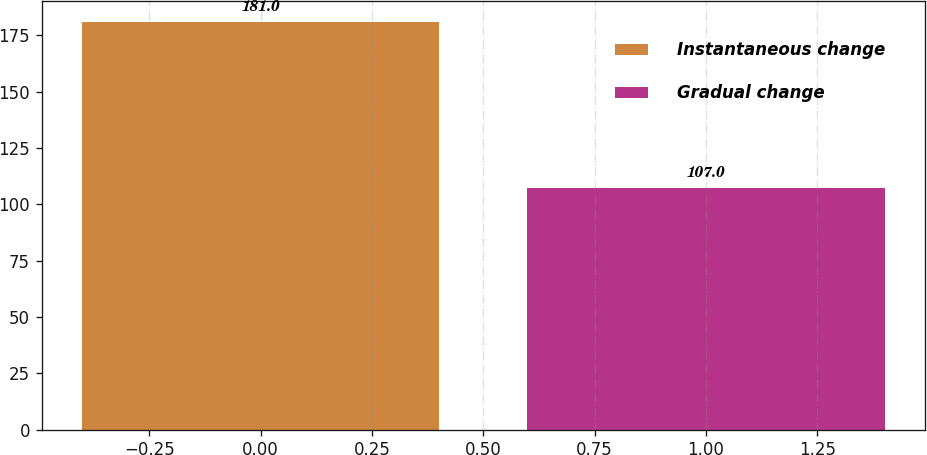<chart> <loc_0><loc_0><loc_500><loc_500><bar_chart><fcel>Instantaneous change<fcel>Gradual change<nl><fcel>181<fcel>107<nl></chart> 